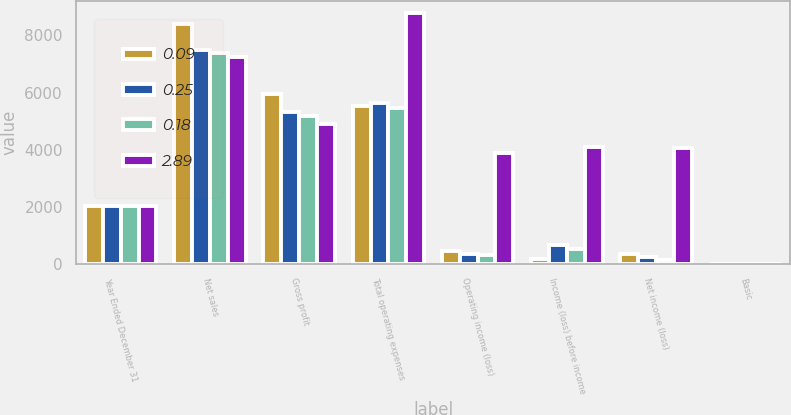Convert chart. <chart><loc_0><loc_0><loc_500><loc_500><stacked_bar_chart><ecel><fcel>Year Ended December 31<fcel>Net sales<fcel>Gross profit<fcel>Total operating expenses<fcel>Operating income (loss)<fcel>Income (loss) before income<fcel>Net income (loss)<fcel>Basic<nl><fcel>0.09<fcel>2016<fcel>8386<fcel>5962<fcel>5515<fcel>447<fcel>177<fcel>347<fcel>0.26<nl><fcel>0.25<fcel>2015<fcel>7477<fcel>5304<fcel>5631<fcel>327<fcel>650<fcel>239<fcel>0.18<nl><fcel>0.18<fcel>2014<fcel>7380<fcel>5170<fcel>5471<fcel>301<fcel>509<fcel>119<fcel>0.09<nl><fcel>2.89<fcel>2012<fcel>7249<fcel>4900<fcel>8768<fcel>3868<fcel>4107<fcel>4068<fcel>2.89<nl></chart> 